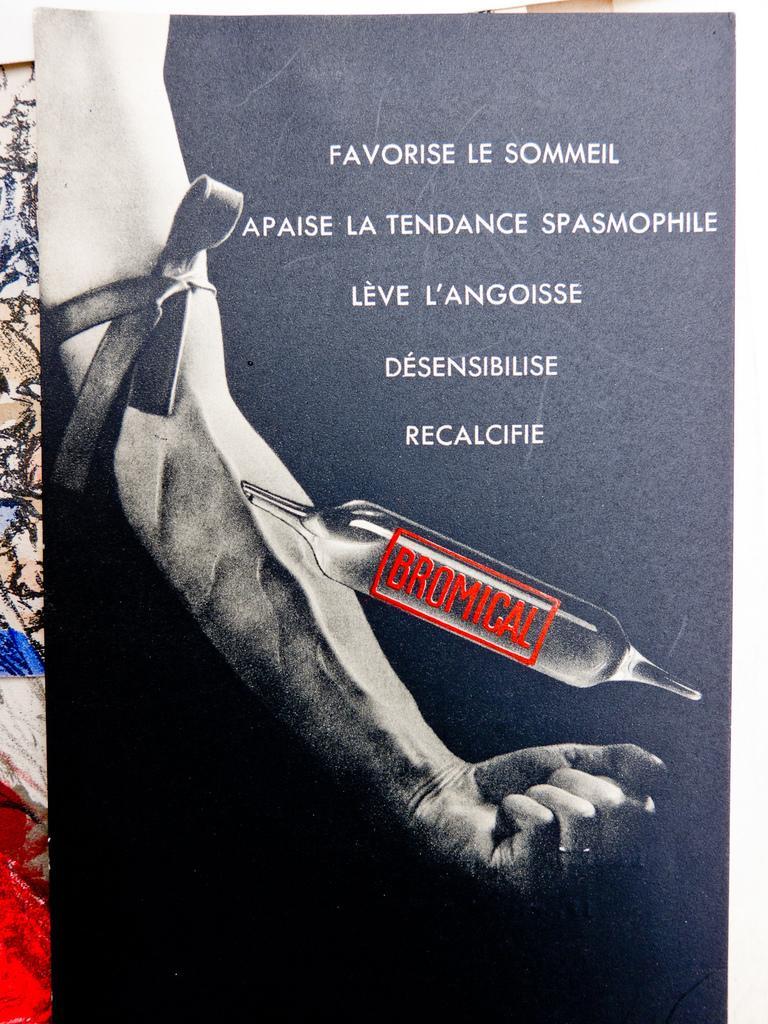Describe this image in one or two sentences. This looks like a poster. I can see a person's hand with a ribbon. These are the letters on the poster. 